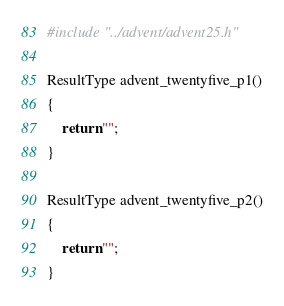Convert code to text. <code><loc_0><loc_0><loc_500><loc_500><_C++_>#include "../advent/advent25.h"

ResultType advent_twentyfive_p1()
{
	return "";
}

ResultType advent_twentyfive_p2()
{
	return "";
}</code> 